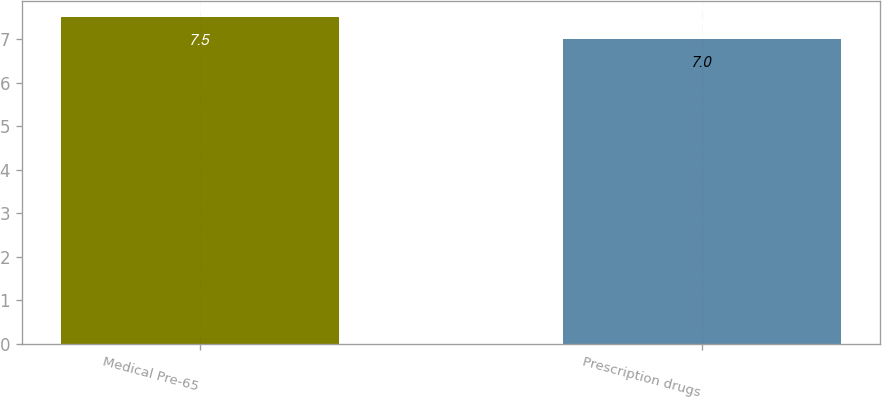<chart> <loc_0><loc_0><loc_500><loc_500><bar_chart><fcel>Medical Pre-65<fcel>Prescription drugs<nl><fcel>7.5<fcel>7<nl></chart> 